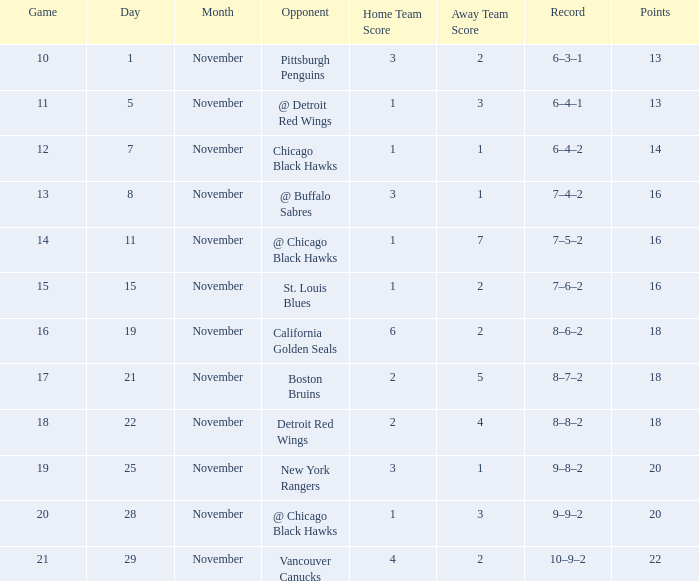Which opponent has points less than 18, and a november greater than 11? St. Louis Blues. 